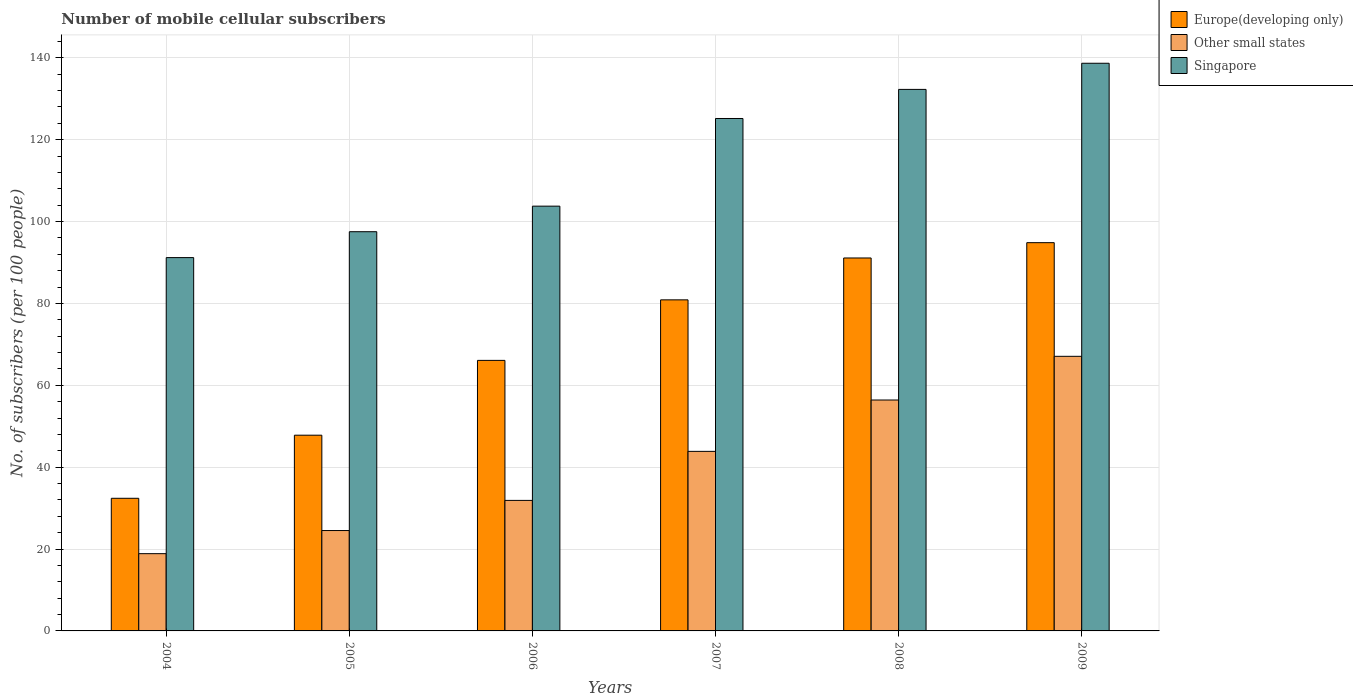How many different coloured bars are there?
Your answer should be compact. 3. Are the number of bars on each tick of the X-axis equal?
Your answer should be compact. Yes. How many bars are there on the 1st tick from the left?
Keep it short and to the point. 3. What is the label of the 1st group of bars from the left?
Your answer should be very brief. 2004. In how many cases, is the number of bars for a given year not equal to the number of legend labels?
Give a very brief answer. 0. What is the number of mobile cellular subscribers in Other small states in 2009?
Give a very brief answer. 67.09. Across all years, what is the maximum number of mobile cellular subscribers in Other small states?
Make the answer very short. 67.09. Across all years, what is the minimum number of mobile cellular subscribers in Europe(developing only)?
Offer a terse response. 32.4. In which year was the number of mobile cellular subscribers in Singapore maximum?
Make the answer very short. 2009. What is the total number of mobile cellular subscribers in Other small states in the graph?
Ensure brevity in your answer.  242.65. What is the difference between the number of mobile cellular subscribers in Europe(developing only) in 2006 and that in 2009?
Provide a succinct answer. -28.76. What is the difference between the number of mobile cellular subscribers in Europe(developing only) in 2009 and the number of mobile cellular subscribers in Other small states in 2006?
Your answer should be very brief. 62.97. What is the average number of mobile cellular subscribers in Europe(developing only) per year?
Ensure brevity in your answer.  68.86. In the year 2007, what is the difference between the number of mobile cellular subscribers in Other small states and number of mobile cellular subscribers in Europe(developing only)?
Offer a terse response. -37.01. What is the ratio of the number of mobile cellular subscribers in Europe(developing only) in 2007 to that in 2009?
Provide a succinct answer. 0.85. Is the number of mobile cellular subscribers in Europe(developing only) in 2004 less than that in 2006?
Provide a succinct answer. Yes. Is the difference between the number of mobile cellular subscribers in Other small states in 2006 and 2009 greater than the difference between the number of mobile cellular subscribers in Europe(developing only) in 2006 and 2009?
Provide a short and direct response. No. What is the difference between the highest and the second highest number of mobile cellular subscribers in Europe(developing only)?
Make the answer very short. 3.74. What is the difference between the highest and the lowest number of mobile cellular subscribers in Singapore?
Your response must be concise. 47.48. What does the 1st bar from the left in 2009 represents?
Give a very brief answer. Europe(developing only). What does the 2nd bar from the right in 2008 represents?
Provide a succinct answer. Other small states. Are the values on the major ticks of Y-axis written in scientific E-notation?
Offer a terse response. No. How many legend labels are there?
Make the answer very short. 3. What is the title of the graph?
Make the answer very short. Number of mobile cellular subscribers. What is the label or title of the X-axis?
Give a very brief answer. Years. What is the label or title of the Y-axis?
Your answer should be very brief. No. of subscribers (per 100 people). What is the No. of subscribers (per 100 people) in Europe(developing only) in 2004?
Offer a very short reply. 32.4. What is the No. of subscribers (per 100 people) in Other small states in 2004?
Provide a short and direct response. 18.87. What is the No. of subscribers (per 100 people) in Singapore in 2004?
Your answer should be very brief. 91.21. What is the No. of subscribers (per 100 people) in Europe(developing only) in 2005?
Keep it short and to the point. 47.82. What is the No. of subscribers (per 100 people) of Other small states in 2005?
Keep it short and to the point. 24.52. What is the No. of subscribers (per 100 people) in Singapore in 2005?
Give a very brief answer. 97.53. What is the No. of subscribers (per 100 people) of Europe(developing only) in 2006?
Offer a very short reply. 66.09. What is the No. of subscribers (per 100 people) in Other small states in 2006?
Keep it short and to the point. 31.89. What is the No. of subscribers (per 100 people) in Singapore in 2006?
Keep it short and to the point. 103.78. What is the No. of subscribers (per 100 people) in Europe(developing only) in 2007?
Offer a terse response. 80.88. What is the No. of subscribers (per 100 people) in Other small states in 2007?
Ensure brevity in your answer.  43.87. What is the No. of subscribers (per 100 people) in Singapore in 2007?
Offer a very short reply. 125.19. What is the No. of subscribers (per 100 people) in Europe(developing only) in 2008?
Offer a terse response. 91.11. What is the No. of subscribers (per 100 people) of Other small states in 2008?
Provide a succinct answer. 56.41. What is the No. of subscribers (per 100 people) in Singapore in 2008?
Keep it short and to the point. 132.3. What is the No. of subscribers (per 100 people) in Europe(developing only) in 2009?
Your answer should be very brief. 94.85. What is the No. of subscribers (per 100 people) of Other small states in 2009?
Your answer should be compact. 67.09. What is the No. of subscribers (per 100 people) of Singapore in 2009?
Your response must be concise. 138.69. Across all years, what is the maximum No. of subscribers (per 100 people) of Europe(developing only)?
Your answer should be compact. 94.85. Across all years, what is the maximum No. of subscribers (per 100 people) in Other small states?
Make the answer very short. 67.09. Across all years, what is the maximum No. of subscribers (per 100 people) of Singapore?
Your answer should be very brief. 138.69. Across all years, what is the minimum No. of subscribers (per 100 people) of Europe(developing only)?
Ensure brevity in your answer.  32.4. Across all years, what is the minimum No. of subscribers (per 100 people) of Other small states?
Offer a terse response. 18.87. Across all years, what is the minimum No. of subscribers (per 100 people) in Singapore?
Give a very brief answer. 91.21. What is the total No. of subscribers (per 100 people) in Europe(developing only) in the graph?
Provide a succinct answer. 413.17. What is the total No. of subscribers (per 100 people) in Other small states in the graph?
Ensure brevity in your answer.  242.65. What is the total No. of subscribers (per 100 people) of Singapore in the graph?
Your answer should be compact. 688.69. What is the difference between the No. of subscribers (per 100 people) in Europe(developing only) in 2004 and that in 2005?
Give a very brief answer. -15.41. What is the difference between the No. of subscribers (per 100 people) of Other small states in 2004 and that in 2005?
Your answer should be very brief. -5.65. What is the difference between the No. of subscribers (per 100 people) in Singapore in 2004 and that in 2005?
Give a very brief answer. -6.32. What is the difference between the No. of subscribers (per 100 people) in Europe(developing only) in 2004 and that in 2006?
Your answer should be very brief. -33.69. What is the difference between the No. of subscribers (per 100 people) of Other small states in 2004 and that in 2006?
Ensure brevity in your answer.  -13.01. What is the difference between the No. of subscribers (per 100 people) in Singapore in 2004 and that in 2006?
Your answer should be very brief. -12.57. What is the difference between the No. of subscribers (per 100 people) of Europe(developing only) in 2004 and that in 2007?
Give a very brief answer. -48.48. What is the difference between the No. of subscribers (per 100 people) in Other small states in 2004 and that in 2007?
Offer a terse response. -24.99. What is the difference between the No. of subscribers (per 100 people) in Singapore in 2004 and that in 2007?
Offer a terse response. -33.98. What is the difference between the No. of subscribers (per 100 people) of Europe(developing only) in 2004 and that in 2008?
Give a very brief answer. -58.71. What is the difference between the No. of subscribers (per 100 people) in Other small states in 2004 and that in 2008?
Keep it short and to the point. -37.54. What is the difference between the No. of subscribers (per 100 people) of Singapore in 2004 and that in 2008?
Your answer should be very brief. -41.09. What is the difference between the No. of subscribers (per 100 people) in Europe(developing only) in 2004 and that in 2009?
Provide a short and direct response. -62.45. What is the difference between the No. of subscribers (per 100 people) in Other small states in 2004 and that in 2009?
Make the answer very short. -48.21. What is the difference between the No. of subscribers (per 100 people) in Singapore in 2004 and that in 2009?
Ensure brevity in your answer.  -47.48. What is the difference between the No. of subscribers (per 100 people) in Europe(developing only) in 2005 and that in 2006?
Give a very brief answer. -18.28. What is the difference between the No. of subscribers (per 100 people) of Other small states in 2005 and that in 2006?
Make the answer very short. -7.36. What is the difference between the No. of subscribers (per 100 people) in Singapore in 2005 and that in 2006?
Your response must be concise. -6.24. What is the difference between the No. of subscribers (per 100 people) in Europe(developing only) in 2005 and that in 2007?
Ensure brevity in your answer.  -33.06. What is the difference between the No. of subscribers (per 100 people) of Other small states in 2005 and that in 2007?
Offer a very short reply. -19.34. What is the difference between the No. of subscribers (per 100 people) in Singapore in 2005 and that in 2007?
Your response must be concise. -27.66. What is the difference between the No. of subscribers (per 100 people) of Europe(developing only) in 2005 and that in 2008?
Give a very brief answer. -43.3. What is the difference between the No. of subscribers (per 100 people) in Other small states in 2005 and that in 2008?
Make the answer very short. -31.89. What is the difference between the No. of subscribers (per 100 people) of Singapore in 2005 and that in 2008?
Your response must be concise. -34.77. What is the difference between the No. of subscribers (per 100 people) of Europe(developing only) in 2005 and that in 2009?
Give a very brief answer. -47.03. What is the difference between the No. of subscribers (per 100 people) of Other small states in 2005 and that in 2009?
Your answer should be compact. -42.56. What is the difference between the No. of subscribers (per 100 people) in Singapore in 2005 and that in 2009?
Make the answer very short. -41.15. What is the difference between the No. of subscribers (per 100 people) of Europe(developing only) in 2006 and that in 2007?
Provide a short and direct response. -14.79. What is the difference between the No. of subscribers (per 100 people) of Other small states in 2006 and that in 2007?
Provide a succinct answer. -11.98. What is the difference between the No. of subscribers (per 100 people) in Singapore in 2006 and that in 2007?
Keep it short and to the point. -21.41. What is the difference between the No. of subscribers (per 100 people) in Europe(developing only) in 2006 and that in 2008?
Offer a terse response. -25.02. What is the difference between the No. of subscribers (per 100 people) in Other small states in 2006 and that in 2008?
Give a very brief answer. -24.53. What is the difference between the No. of subscribers (per 100 people) in Singapore in 2006 and that in 2008?
Offer a terse response. -28.52. What is the difference between the No. of subscribers (per 100 people) in Europe(developing only) in 2006 and that in 2009?
Keep it short and to the point. -28.76. What is the difference between the No. of subscribers (per 100 people) of Other small states in 2006 and that in 2009?
Your answer should be very brief. -35.2. What is the difference between the No. of subscribers (per 100 people) of Singapore in 2006 and that in 2009?
Provide a succinct answer. -34.91. What is the difference between the No. of subscribers (per 100 people) in Europe(developing only) in 2007 and that in 2008?
Ensure brevity in your answer.  -10.23. What is the difference between the No. of subscribers (per 100 people) of Other small states in 2007 and that in 2008?
Provide a short and direct response. -12.55. What is the difference between the No. of subscribers (per 100 people) of Singapore in 2007 and that in 2008?
Provide a succinct answer. -7.11. What is the difference between the No. of subscribers (per 100 people) of Europe(developing only) in 2007 and that in 2009?
Give a very brief answer. -13.97. What is the difference between the No. of subscribers (per 100 people) in Other small states in 2007 and that in 2009?
Ensure brevity in your answer.  -23.22. What is the difference between the No. of subscribers (per 100 people) in Singapore in 2007 and that in 2009?
Give a very brief answer. -13.5. What is the difference between the No. of subscribers (per 100 people) of Europe(developing only) in 2008 and that in 2009?
Provide a succinct answer. -3.74. What is the difference between the No. of subscribers (per 100 people) in Other small states in 2008 and that in 2009?
Your answer should be very brief. -10.67. What is the difference between the No. of subscribers (per 100 people) of Singapore in 2008 and that in 2009?
Your response must be concise. -6.39. What is the difference between the No. of subscribers (per 100 people) of Europe(developing only) in 2004 and the No. of subscribers (per 100 people) of Other small states in 2005?
Offer a very short reply. 7.88. What is the difference between the No. of subscribers (per 100 people) of Europe(developing only) in 2004 and the No. of subscribers (per 100 people) of Singapore in 2005?
Ensure brevity in your answer.  -65.13. What is the difference between the No. of subscribers (per 100 people) in Other small states in 2004 and the No. of subscribers (per 100 people) in Singapore in 2005?
Your answer should be very brief. -78.66. What is the difference between the No. of subscribers (per 100 people) of Europe(developing only) in 2004 and the No. of subscribers (per 100 people) of Other small states in 2006?
Offer a very short reply. 0.52. What is the difference between the No. of subscribers (per 100 people) in Europe(developing only) in 2004 and the No. of subscribers (per 100 people) in Singapore in 2006?
Provide a succinct answer. -71.37. What is the difference between the No. of subscribers (per 100 people) in Other small states in 2004 and the No. of subscribers (per 100 people) in Singapore in 2006?
Provide a succinct answer. -84.9. What is the difference between the No. of subscribers (per 100 people) in Europe(developing only) in 2004 and the No. of subscribers (per 100 people) in Other small states in 2007?
Your response must be concise. -11.46. What is the difference between the No. of subscribers (per 100 people) in Europe(developing only) in 2004 and the No. of subscribers (per 100 people) in Singapore in 2007?
Offer a very short reply. -92.79. What is the difference between the No. of subscribers (per 100 people) of Other small states in 2004 and the No. of subscribers (per 100 people) of Singapore in 2007?
Your answer should be compact. -106.32. What is the difference between the No. of subscribers (per 100 people) of Europe(developing only) in 2004 and the No. of subscribers (per 100 people) of Other small states in 2008?
Make the answer very short. -24.01. What is the difference between the No. of subscribers (per 100 people) in Europe(developing only) in 2004 and the No. of subscribers (per 100 people) in Singapore in 2008?
Keep it short and to the point. -99.9. What is the difference between the No. of subscribers (per 100 people) of Other small states in 2004 and the No. of subscribers (per 100 people) of Singapore in 2008?
Provide a short and direct response. -113.43. What is the difference between the No. of subscribers (per 100 people) of Europe(developing only) in 2004 and the No. of subscribers (per 100 people) of Other small states in 2009?
Provide a succinct answer. -34.68. What is the difference between the No. of subscribers (per 100 people) in Europe(developing only) in 2004 and the No. of subscribers (per 100 people) in Singapore in 2009?
Keep it short and to the point. -106.28. What is the difference between the No. of subscribers (per 100 people) in Other small states in 2004 and the No. of subscribers (per 100 people) in Singapore in 2009?
Give a very brief answer. -119.81. What is the difference between the No. of subscribers (per 100 people) in Europe(developing only) in 2005 and the No. of subscribers (per 100 people) in Other small states in 2006?
Keep it short and to the point. 15.93. What is the difference between the No. of subscribers (per 100 people) of Europe(developing only) in 2005 and the No. of subscribers (per 100 people) of Singapore in 2006?
Give a very brief answer. -55.96. What is the difference between the No. of subscribers (per 100 people) in Other small states in 2005 and the No. of subscribers (per 100 people) in Singapore in 2006?
Keep it short and to the point. -79.25. What is the difference between the No. of subscribers (per 100 people) in Europe(developing only) in 2005 and the No. of subscribers (per 100 people) in Other small states in 2007?
Offer a terse response. 3.95. What is the difference between the No. of subscribers (per 100 people) of Europe(developing only) in 2005 and the No. of subscribers (per 100 people) of Singapore in 2007?
Offer a very short reply. -77.37. What is the difference between the No. of subscribers (per 100 people) of Other small states in 2005 and the No. of subscribers (per 100 people) of Singapore in 2007?
Provide a succinct answer. -100.67. What is the difference between the No. of subscribers (per 100 people) of Europe(developing only) in 2005 and the No. of subscribers (per 100 people) of Other small states in 2008?
Provide a succinct answer. -8.6. What is the difference between the No. of subscribers (per 100 people) of Europe(developing only) in 2005 and the No. of subscribers (per 100 people) of Singapore in 2008?
Offer a terse response. -84.48. What is the difference between the No. of subscribers (per 100 people) in Other small states in 2005 and the No. of subscribers (per 100 people) in Singapore in 2008?
Your answer should be very brief. -107.78. What is the difference between the No. of subscribers (per 100 people) of Europe(developing only) in 2005 and the No. of subscribers (per 100 people) of Other small states in 2009?
Ensure brevity in your answer.  -19.27. What is the difference between the No. of subscribers (per 100 people) of Europe(developing only) in 2005 and the No. of subscribers (per 100 people) of Singapore in 2009?
Offer a very short reply. -90.87. What is the difference between the No. of subscribers (per 100 people) of Other small states in 2005 and the No. of subscribers (per 100 people) of Singapore in 2009?
Keep it short and to the point. -114.16. What is the difference between the No. of subscribers (per 100 people) in Europe(developing only) in 2006 and the No. of subscribers (per 100 people) in Other small states in 2007?
Provide a short and direct response. 22.23. What is the difference between the No. of subscribers (per 100 people) of Europe(developing only) in 2006 and the No. of subscribers (per 100 people) of Singapore in 2007?
Keep it short and to the point. -59.1. What is the difference between the No. of subscribers (per 100 people) in Other small states in 2006 and the No. of subscribers (per 100 people) in Singapore in 2007?
Provide a succinct answer. -93.3. What is the difference between the No. of subscribers (per 100 people) in Europe(developing only) in 2006 and the No. of subscribers (per 100 people) in Other small states in 2008?
Your answer should be compact. 9.68. What is the difference between the No. of subscribers (per 100 people) of Europe(developing only) in 2006 and the No. of subscribers (per 100 people) of Singapore in 2008?
Your response must be concise. -66.21. What is the difference between the No. of subscribers (per 100 people) of Other small states in 2006 and the No. of subscribers (per 100 people) of Singapore in 2008?
Your answer should be very brief. -100.41. What is the difference between the No. of subscribers (per 100 people) of Europe(developing only) in 2006 and the No. of subscribers (per 100 people) of Other small states in 2009?
Offer a very short reply. -0.99. What is the difference between the No. of subscribers (per 100 people) in Europe(developing only) in 2006 and the No. of subscribers (per 100 people) in Singapore in 2009?
Offer a terse response. -72.59. What is the difference between the No. of subscribers (per 100 people) of Other small states in 2006 and the No. of subscribers (per 100 people) of Singapore in 2009?
Ensure brevity in your answer.  -106.8. What is the difference between the No. of subscribers (per 100 people) of Europe(developing only) in 2007 and the No. of subscribers (per 100 people) of Other small states in 2008?
Provide a succinct answer. 24.47. What is the difference between the No. of subscribers (per 100 people) of Europe(developing only) in 2007 and the No. of subscribers (per 100 people) of Singapore in 2008?
Your response must be concise. -51.42. What is the difference between the No. of subscribers (per 100 people) of Other small states in 2007 and the No. of subscribers (per 100 people) of Singapore in 2008?
Give a very brief answer. -88.43. What is the difference between the No. of subscribers (per 100 people) in Europe(developing only) in 2007 and the No. of subscribers (per 100 people) in Other small states in 2009?
Your answer should be very brief. 13.8. What is the difference between the No. of subscribers (per 100 people) of Europe(developing only) in 2007 and the No. of subscribers (per 100 people) of Singapore in 2009?
Your answer should be compact. -57.8. What is the difference between the No. of subscribers (per 100 people) in Other small states in 2007 and the No. of subscribers (per 100 people) in Singapore in 2009?
Give a very brief answer. -94.82. What is the difference between the No. of subscribers (per 100 people) of Europe(developing only) in 2008 and the No. of subscribers (per 100 people) of Other small states in 2009?
Keep it short and to the point. 24.03. What is the difference between the No. of subscribers (per 100 people) of Europe(developing only) in 2008 and the No. of subscribers (per 100 people) of Singapore in 2009?
Give a very brief answer. -47.57. What is the difference between the No. of subscribers (per 100 people) of Other small states in 2008 and the No. of subscribers (per 100 people) of Singapore in 2009?
Provide a succinct answer. -82.27. What is the average No. of subscribers (per 100 people) of Europe(developing only) per year?
Make the answer very short. 68.86. What is the average No. of subscribers (per 100 people) in Other small states per year?
Ensure brevity in your answer.  40.44. What is the average No. of subscribers (per 100 people) in Singapore per year?
Provide a succinct answer. 114.78. In the year 2004, what is the difference between the No. of subscribers (per 100 people) of Europe(developing only) and No. of subscribers (per 100 people) of Other small states?
Make the answer very short. 13.53. In the year 2004, what is the difference between the No. of subscribers (per 100 people) in Europe(developing only) and No. of subscribers (per 100 people) in Singapore?
Your answer should be very brief. -58.8. In the year 2004, what is the difference between the No. of subscribers (per 100 people) of Other small states and No. of subscribers (per 100 people) of Singapore?
Your response must be concise. -72.33. In the year 2005, what is the difference between the No. of subscribers (per 100 people) in Europe(developing only) and No. of subscribers (per 100 people) in Other small states?
Give a very brief answer. 23.29. In the year 2005, what is the difference between the No. of subscribers (per 100 people) of Europe(developing only) and No. of subscribers (per 100 people) of Singapore?
Offer a very short reply. -49.71. In the year 2005, what is the difference between the No. of subscribers (per 100 people) of Other small states and No. of subscribers (per 100 people) of Singapore?
Keep it short and to the point. -73.01. In the year 2006, what is the difference between the No. of subscribers (per 100 people) of Europe(developing only) and No. of subscribers (per 100 people) of Other small states?
Your response must be concise. 34.21. In the year 2006, what is the difference between the No. of subscribers (per 100 people) of Europe(developing only) and No. of subscribers (per 100 people) of Singapore?
Provide a succinct answer. -37.68. In the year 2006, what is the difference between the No. of subscribers (per 100 people) of Other small states and No. of subscribers (per 100 people) of Singapore?
Offer a terse response. -71.89. In the year 2007, what is the difference between the No. of subscribers (per 100 people) of Europe(developing only) and No. of subscribers (per 100 people) of Other small states?
Make the answer very short. 37.01. In the year 2007, what is the difference between the No. of subscribers (per 100 people) in Europe(developing only) and No. of subscribers (per 100 people) in Singapore?
Give a very brief answer. -44.31. In the year 2007, what is the difference between the No. of subscribers (per 100 people) of Other small states and No. of subscribers (per 100 people) of Singapore?
Offer a terse response. -81.32. In the year 2008, what is the difference between the No. of subscribers (per 100 people) of Europe(developing only) and No. of subscribers (per 100 people) of Other small states?
Offer a terse response. 34.7. In the year 2008, what is the difference between the No. of subscribers (per 100 people) of Europe(developing only) and No. of subscribers (per 100 people) of Singapore?
Provide a succinct answer. -41.19. In the year 2008, what is the difference between the No. of subscribers (per 100 people) of Other small states and No. of subscribers (per 100 people) of Singapore?
Provide a short and direct response. -75.89. In the year 2009, what is the difference between the No. of subscribers (per 100 people) of Europe(developing only) and No. of subscribers (per 100 people) of Other small states?
Offer a very short reply. 27.77. In the year 2009, what is the difference between the No. of subscribers (per 100 people) of Europe(developing only) and No. of subscribers (per 100 people) of Singapore?
Offer a terse response. -43.83. In the year 2009, what is the difference between the No. of subscribers (per 100 people) in Other small states and No. of subscribers (per 100 people) in Singapore?
Your answer should be very brief. -71.6. What is the ratio of the No. of subscribers (per 100 people) in Europe(developing only) in 2004 to that in 2005?
Ensure brevity in your answer.  0.68. What is the ratio of the No. of subscribers (per 100 people) of Other small states in 2004 to that in 2005?
Make the answer very short. 0.77. What is the ratio of the No. of subscribers (per 100 people) of Singapore in 2004 to that in 2005?
Provide a succinct answer. 0.94. What is the ratio of the No. of subscribers (per 100 people) of Europe(developing only) in 2004 to that in 2006?
Provide a short and direct response. 0.49. What is the ratio of the No. of subscribers (per 100 people) in Other small states in 2004 to that in 2006?
Offer a very short reply. 0.59. What is the ratio of the No. of subscribers (per 100 people) in Singapore in 2004 to that in 2006?
Your answer should be compact. 0.88. What is the ratio of the No. of subscribers (per 100 people) of Europe(developing only) in 2004 to that in 2007?
Provide a short and direct response. 0.4. What is the ratio of the No. of subscribers (per 100 people) of Other small states in 2004 to that in 2007?
Ensure brevity in your answer.  0.43. What is the ratio of the No. of subscribers (per 100 people) of Singapore in 2004 to that in 2007?
Offer a terse response. 0.73. What is the ratio of the No. of subscribers (per 100 people) of Europe(developing only) in 2004 to that in 2008?
Make the answer very short. 0.36. What is the ratio of the No. of subscribers (per 100 people) in Other small states in 2004 to that in 2008?
Offer a very short reply. 0.33. What is the ratio of the No. of subscribers (per 100 people) in Singapore in 2004 to that in 2008?
Make the answer very short. 0.69. What is the ratio of the No. of subscribers (per 100 people) of Europe(developing only) in 2004 to that in 2009?
Your response must be concise. 0.34. What is the ratio of the No. of subscribers (per 100 people) of Other small states in 2004 to that in 2009?
Offer a terse response. 0.28. What is the ratio of the No. of subscribers (per 100 people) in Singapore in 2004 to that in 2009?
Your answer should be compact. 0.66. What is the ratio of the No. of subscribers (per 100 people) in Europe(developing only) in 2005 to that in 2006?
Offer a very short reply. 0.72. What is the ratio of the No. of subscribers (per 100 people) of Other small states in 2005 to that in 2006?
Your response must be concise. 0.77. What is the ratio of the No. of subscribers (per 100 people) in Singapore in 2005 to that in 2006?
Give a very brief answer. 0.94. What is the ratio of the No. of subscribers (per 100 people) of Europe(developing only) in 2005 to that in 2007?
Your response must be concise. 0.59. What is the ratio of the No. of subscribers (per 100 people) of Other small states in 2005 to that in 2007?
Provide a short and direct response. 0.56. What is the ratio of the No. of subscribers (per 100 people) in Singapore in 2005 to that in 2007?
Your answer should be compact. 0.78. What is the ratio of the No. of subscribers (per 100 people) in Europe(developing only) in 2005 to that in 2008?
Provide a succinct answer. 0.52. What is the ratio of the No. of subscribers (per 100 people) of Other small states in 2005 to that in 2008?
Ensure brevity in your answer.  0.43. What is the ratio of the No. of subscribers (per 100 people) in Singapore in 2005 to that in 2008?
Offer a very short reply. 0.74. What is the ratio of the No. of subscribers (per 100 people) of Europe(developing only) in 2005 to that in 2009?
Give a very brief answer. 0.5. What is the ratio of the No. of subscribers (per 100 people) of Other small states in 2005 to that in 2009?
Offer a very short reply. 0.37. What is the ratio of the No. of subscribers (per 100 people) of Singapore in 2005 to that in 2009?
Keep it short and to the point. 0.7. What is the ratio of the No. of subscribers (per 100 people) of Europe(developing only) in 2006 to that in 2007?
Offer a very short reply. 0.82. What is the ratio of the No. of subscribers (per 100 people) in Other small states in 2006 to that in 2007?
Provide a succinct answer. 0.73. What is the ratio of the No. of subscribers (per 100 people) in Singapore in 2006 to that in 2007?
Ensure brevity in your answer.  0.83. What is the ratio of the No. of subscribers (per 100 people) of Europe(developing only) in 2006 to that in 2008?
Keep it short and to the point. 0.73. What is the ratio of the No. of subscribers (per 100 people) in Other small states in 2006 to that in 2008?
Your answer should be compact. 0.57. What is the ratio of the No. of subscribers (per 100 people) in Singapore in 2006 to that in 2008?
Ensure brevity in your answer.  0.78. What is the ratio of the No. of subscribers (per 100 people) in Europe(developing only) in 2006 to that in 2009?
Your answer should be compact. 0.7. What is the ratio of the No. of subscribers (per 100 people) in Other small states in 2006 to that in 2009?
Provide a succinct answer. 0.48. What is the ratio of the No. of subscribers (per 100 people) of Singapore in 2006 to that in 2009?
Offer a terse response. 0.75. What is the ratio of the No. of subscribers (per 100 people) of Europe(developing only) in 2007 to that in 2008?
Provide a short and direct response. 0.89. What is the ratio of the No. of subscribers (per 100 people) of Other small states in 2007 to that in 2008?
Your answer should be compact. 0.78. What is the ratio of the No. of subscribers (per 100 people) in Singapore in 2007 to that in 2008?
Provide a short and direct response. 0.95. What is the ratio of the No. of subscribers (per 100 people) of Europe(developing only) in 2007 to that in 2009?
Keep it short and to the point. 0.85. What is the ratio of the No. of subscribers (per 100 people) in Other small states in 2007 to that in 2009?
Your answer should be very brief. 0.65. What is the ratio of the No. of subscribers (per 100 people) in Singapore in 2007 to that in 2009?
Make the answer very short. 0.9. What is the ratio of the No. of subscribers (per 100 people) in Europe(developing only) in 2008 to that in 2009?
Ensure brevity in your answer.  0.96. What is the ratio of the No. of subscribers (per 100 people) of Other small states in 2008 to that in 2009?
Your answer should be compact. 0.84. What is the ratio of the No. of subscribers (per 100 people) of Singapore in 2008 to that in 2009?
Your response must be concise. 0.95. What is the difference between the highest and the second highest No. of subscribers (per 100 people) of Europe(developing only)?
Offer a very short reply. 3.74. What is the difference between the highest and the second highest No. of subscribers (per 100 people) of Other small states?
Your response must be concise. 10.67. What is the difference between the highest and the second highest No. of subscribers (per 100 people) in Singapore?
Offer a very short reply. 6.39. What is the difference between the highest and the lowest No. of subscribers (per 100 people) of Europe(developing only)?
Make the answer very short. 62.45. What is the difference between the highest and the lowest No. of subscribers (per 100 people) of Other small states?
Keep it short and to the point. 48.21. What is the difference between the highest and the lowest No. of subscribers (per 100 people) in Singapore?
Provide a short and direct response. 47.48. 